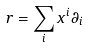Convert formula to latex. <formula><loc_0><loc_0><loc_500><loc_500>r = \sum _ { i } x ^ { i } \partial _ { i }</formula> 